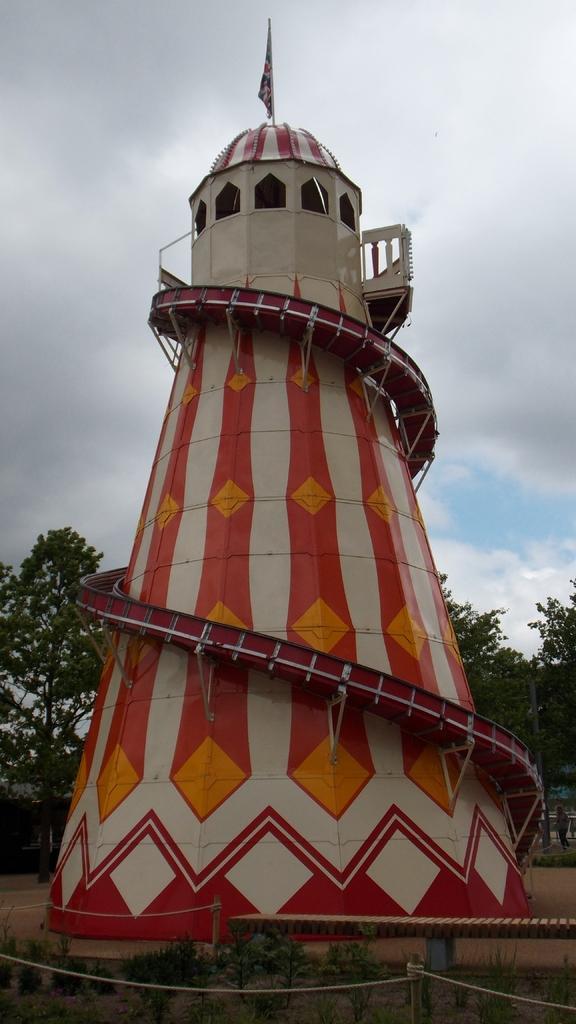Could you give a brief overview of what you see in this image? In this image there is a tower with a flag , and in the background there are trees, plants,sky. 